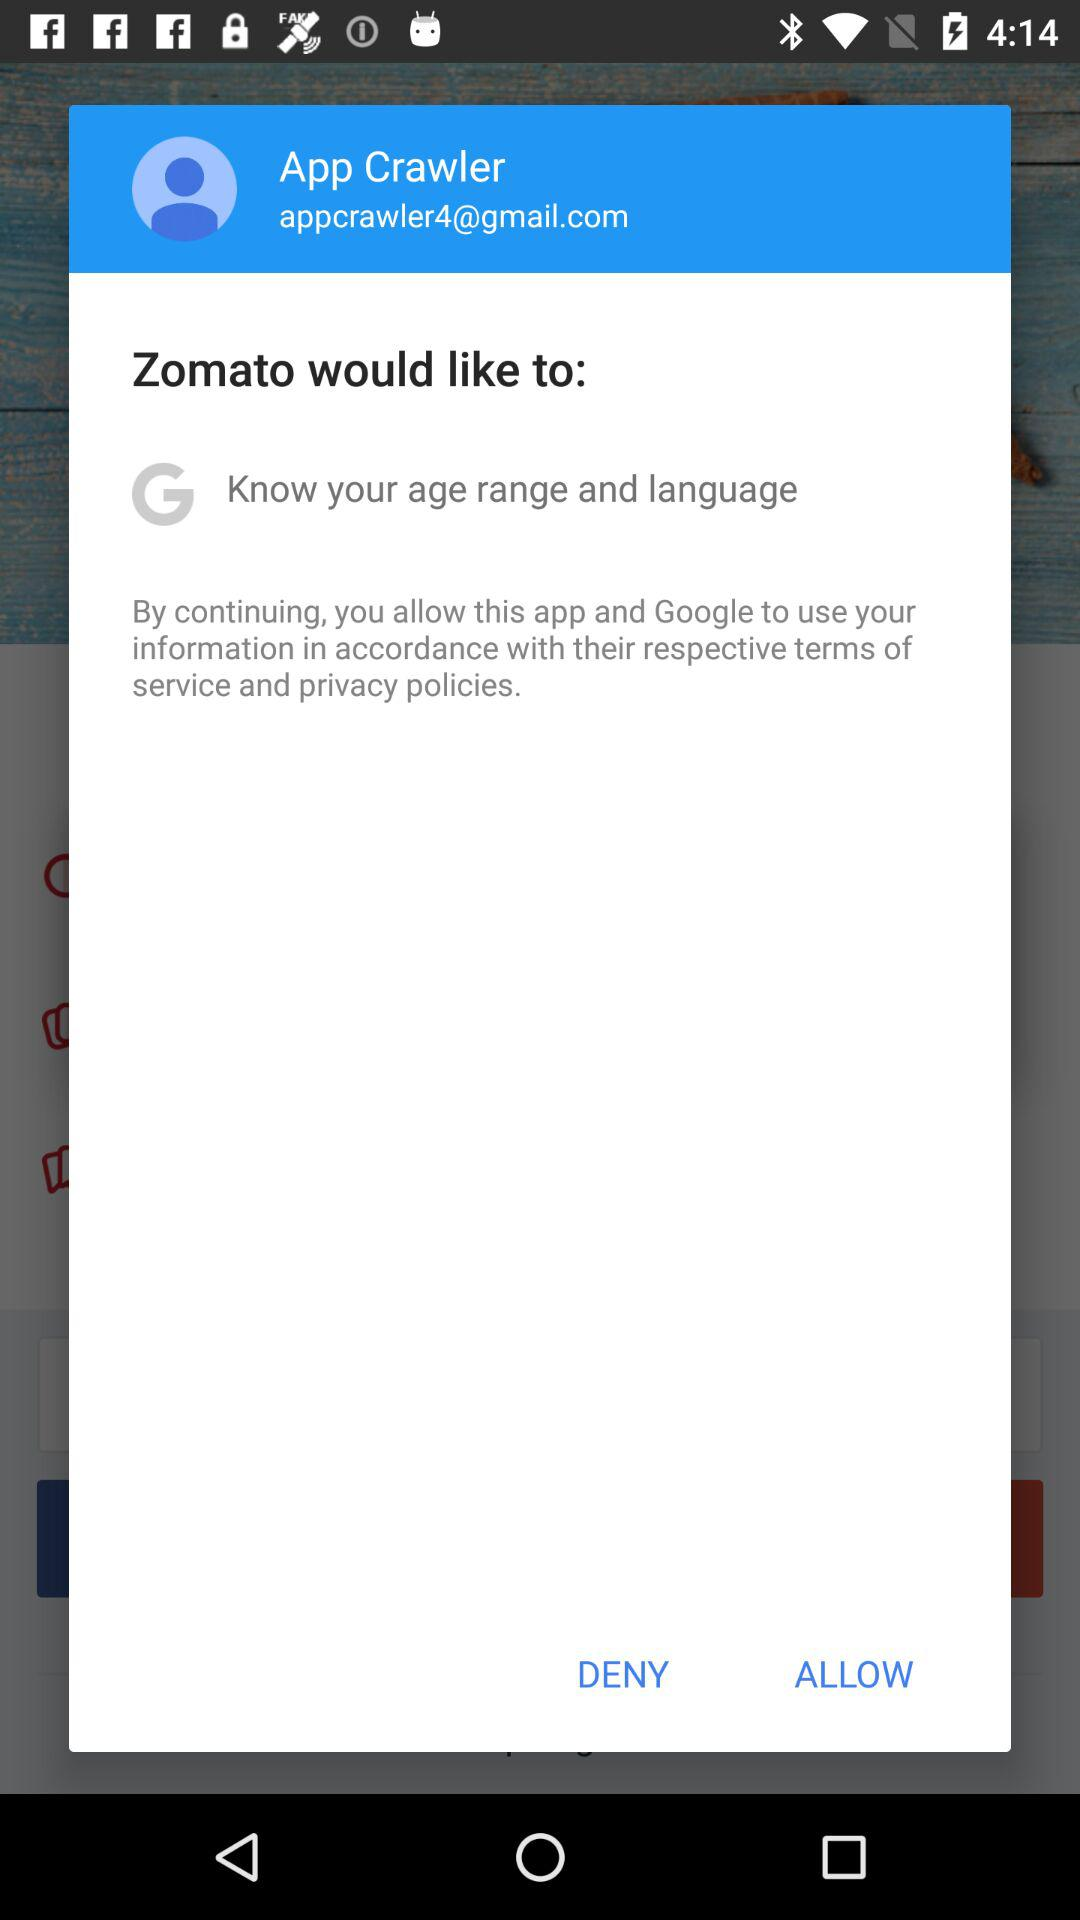What application wants to know the age range and language? The application is "Zomato". 